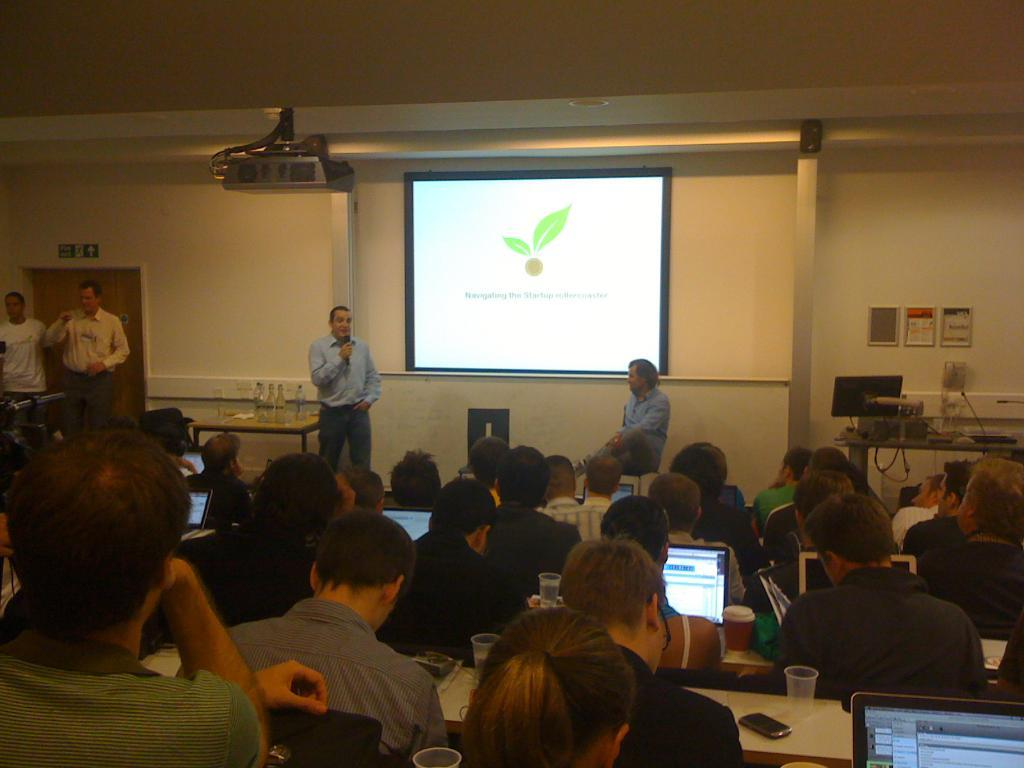What are the people in the image doing? The group of people is sitting on chairs in the image. What objects can be seen in front of the people? There are laptops, glasses, mobile devices, tables, and bottles in front of the people. What is the purpose of the screen in front of the people? The screen in front of the people is likely used for displaying information or presentations. How many people are in the group? There are four people in the group. What can be seen on the wall in the image? The wall visible in the image does not provide any specific details about its contents. How does the group of people achieve development and harmony in the image? There is no information in the image about the group's development or harmony. What type of drain is visible in the image? There is no drain present in the image. 